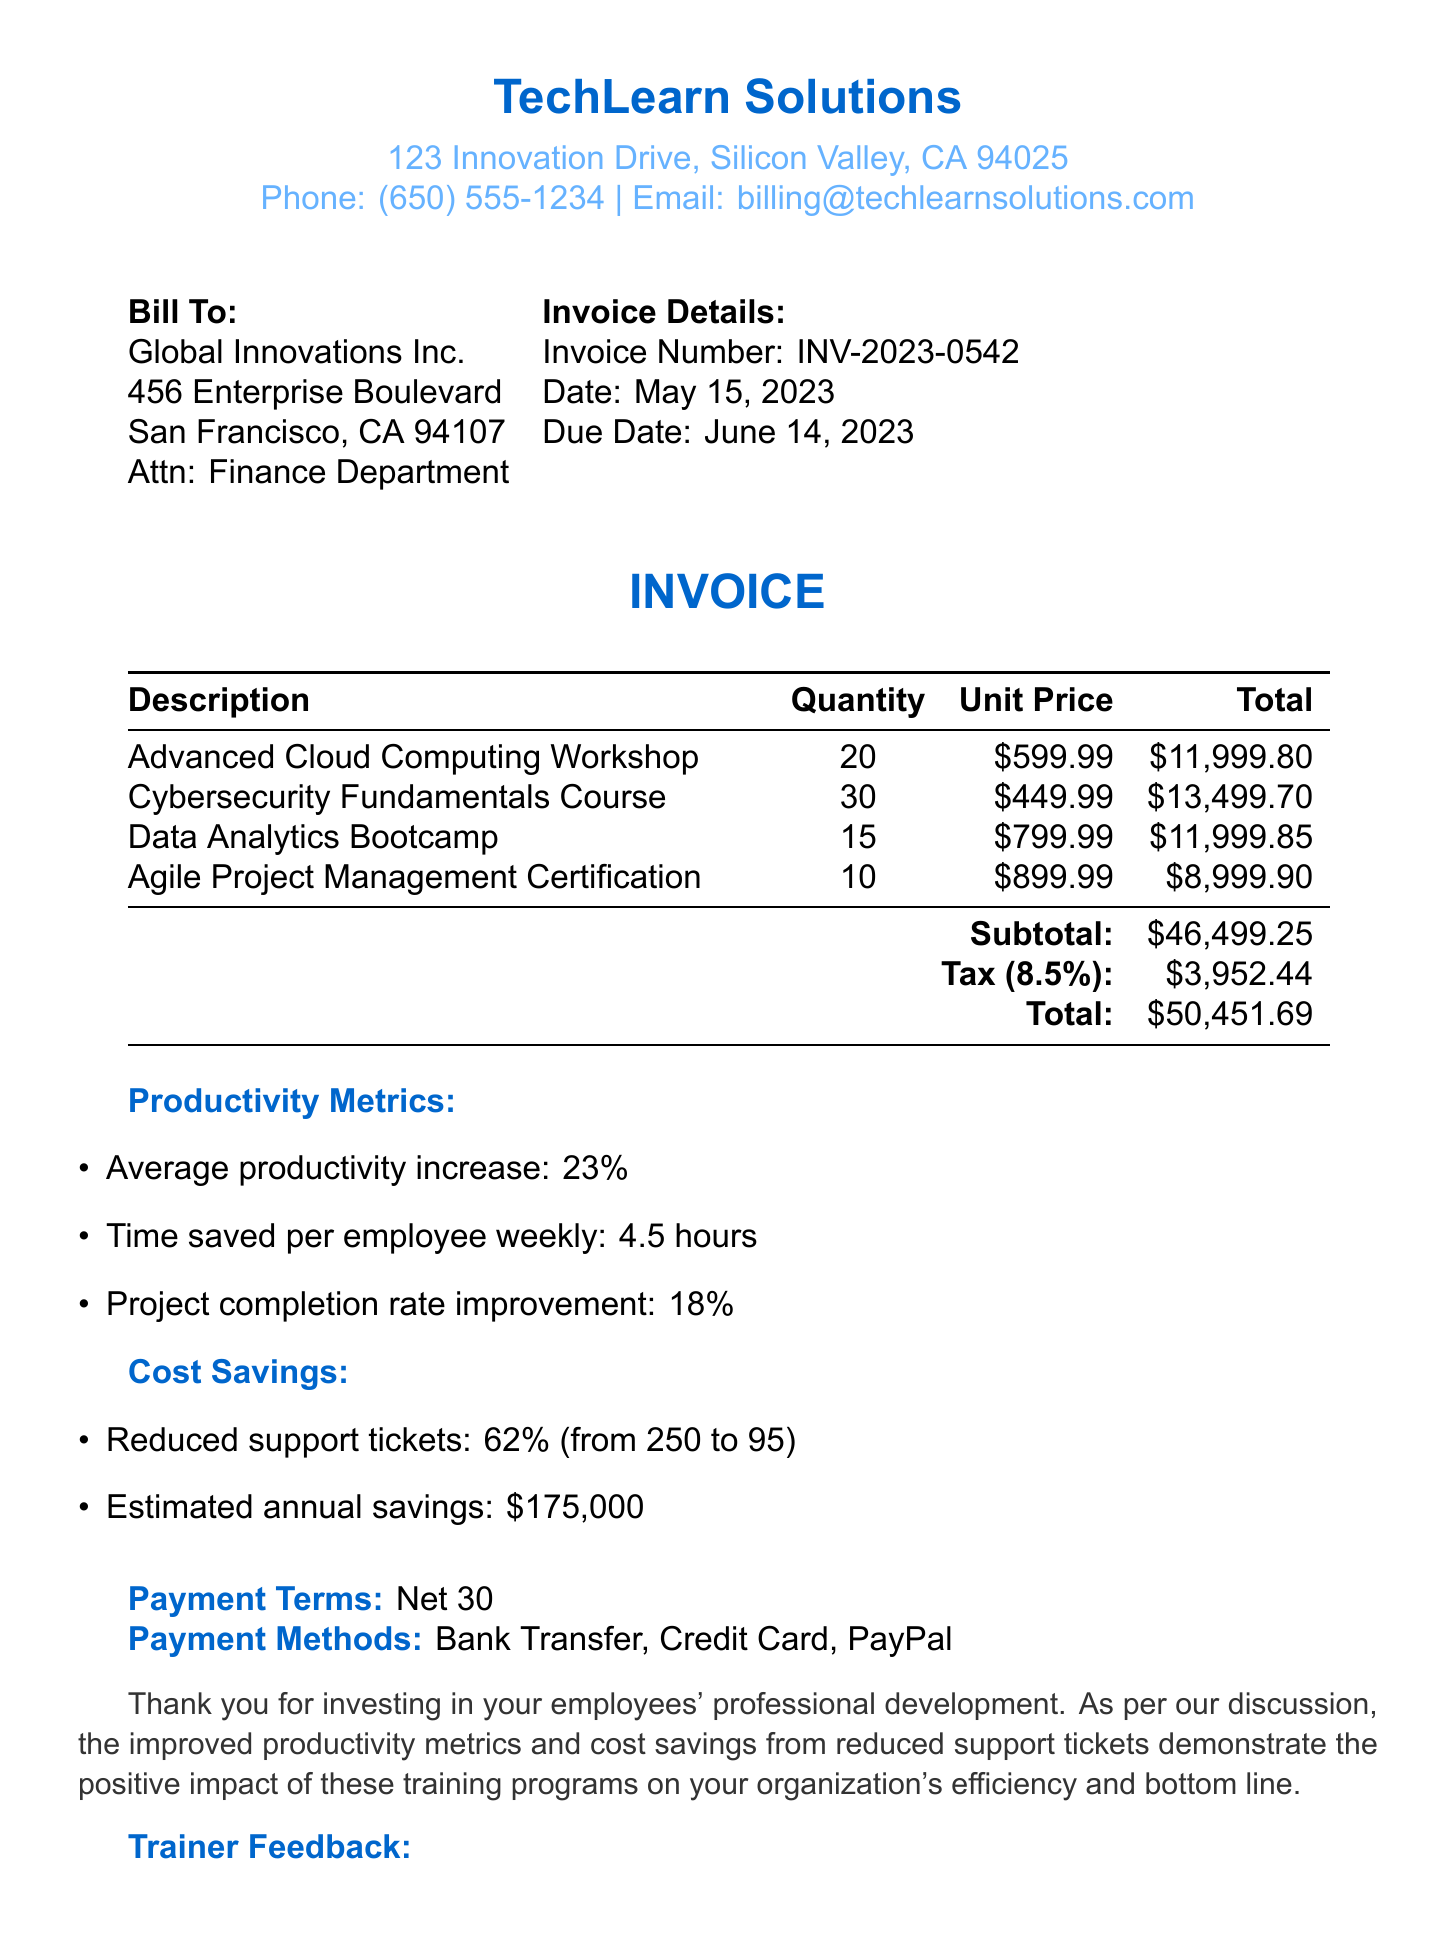What is the invoice number? The invoice number is a unique identifier for this invoice, mentioned clearly in the document.
Answer: INV-2023-0542 What is the total amount due? The total amount is calculated by adding the subtotal and tax amount in the invoice.
Answer: $50,451.69 How many employees attended the Cybersecurity Fundamentals Course? The number of employees for each training is explicitly listed next to the course description.
Answer: 30 employees What is the average productivity increase mentioned in the invoice? The average productivity increase is detailed under the productivity metrics section of the document.
Answer: 23% How much did support tickets reduce after the training? This value is stated in the cost savings section and requires understanding both the before and after numbers provided.
Answer: 62% What are the payment methods listed in the invoice? The invoice clearly states the acceptable payment methods for this transaction.
Answer: Bank Transfer, Credit Card, PayPal What is the due date of the invoice? The due date is specified in the invoice details section.
Answer: June 14, 2023 What is the estimated annual savings from reduced support tickets? This is highlighted in the cost savings section and provides insight into the financial impact of training.
Answer: $175,000 What feedback did the trainer provide for the Data Analytics Bootcamp? Trainer feedback is included in a list format, detailing responses for each course.
Answer: The team now possesses the skills to derive actionable insights from complex datasets 